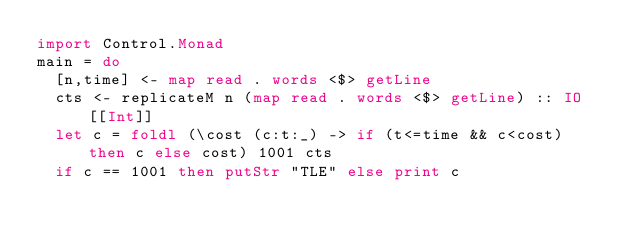<code> <loc_0><loc_0><loc_500><loc_500><_Haskell_>import Control.Monad
main = do
  [n,time] <- map read . words <$> getLine
  cts <- replicateM n (map read . words <$> getLine) :: IO [[Int]]
  let c = foldl (\cost (c:t:_) -> if (t<=time && c<cost) then c else cost) 1001 cts
  if c == 1001 then putStr "TLE" else print c</code> 